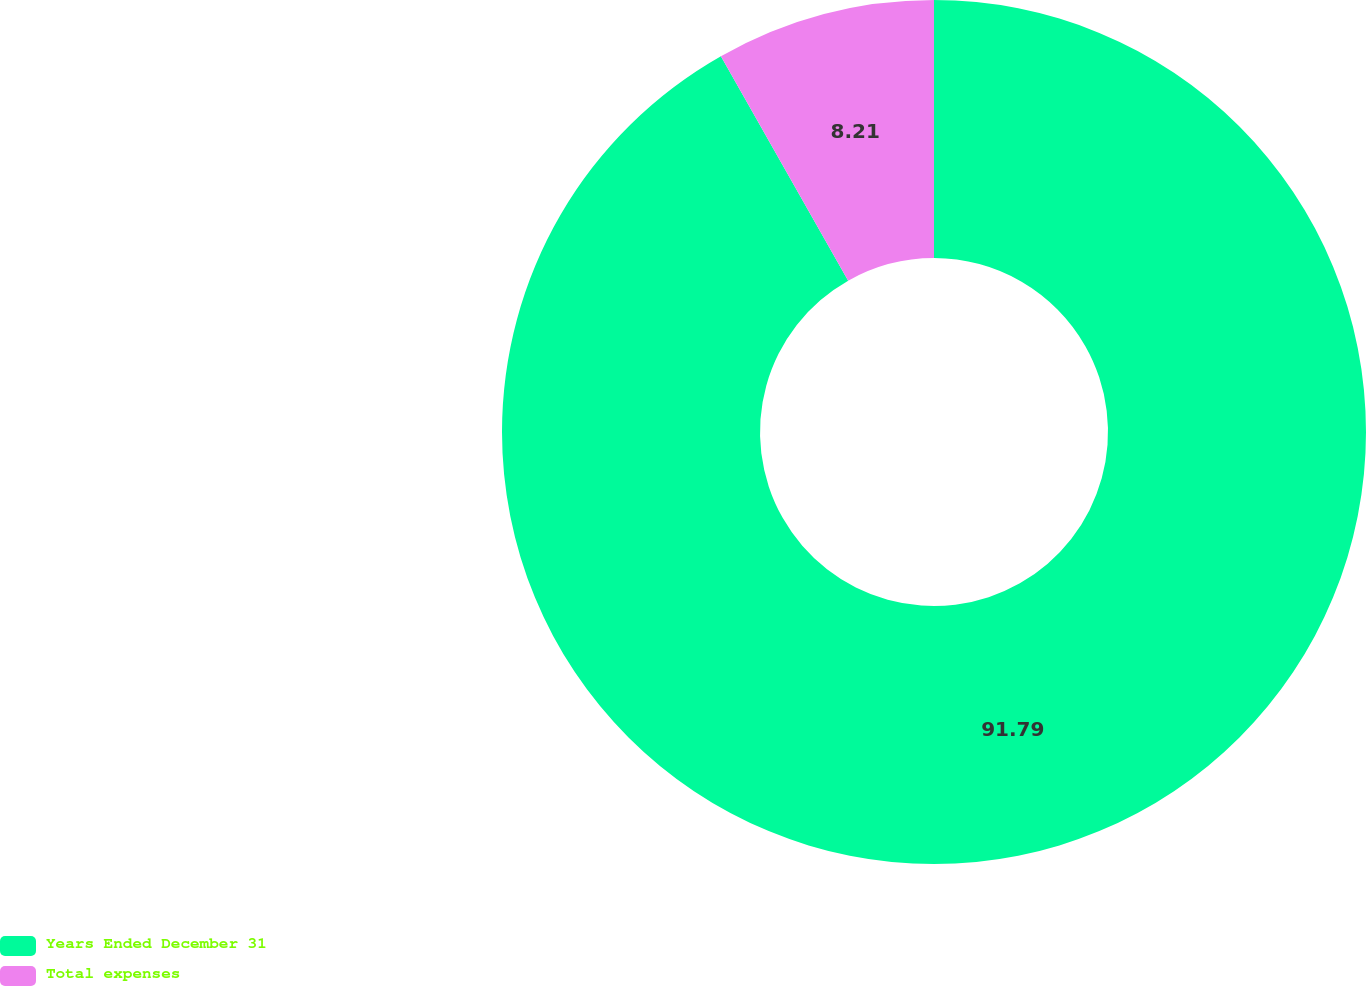Convert chart. <chart><loc_0><loc_0><loc_500><loc_500><pie_chart><fcel>Years Ended December 31<fcel>Total expenses<nl><fcel>91.79%<fcel>8.21%<nl></chart> 